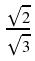<formula> <loc_0><loc_0><loc_500><loc_500>\frac { \sqrt { 2 } } { \sqrt { 3 } }</formula> 